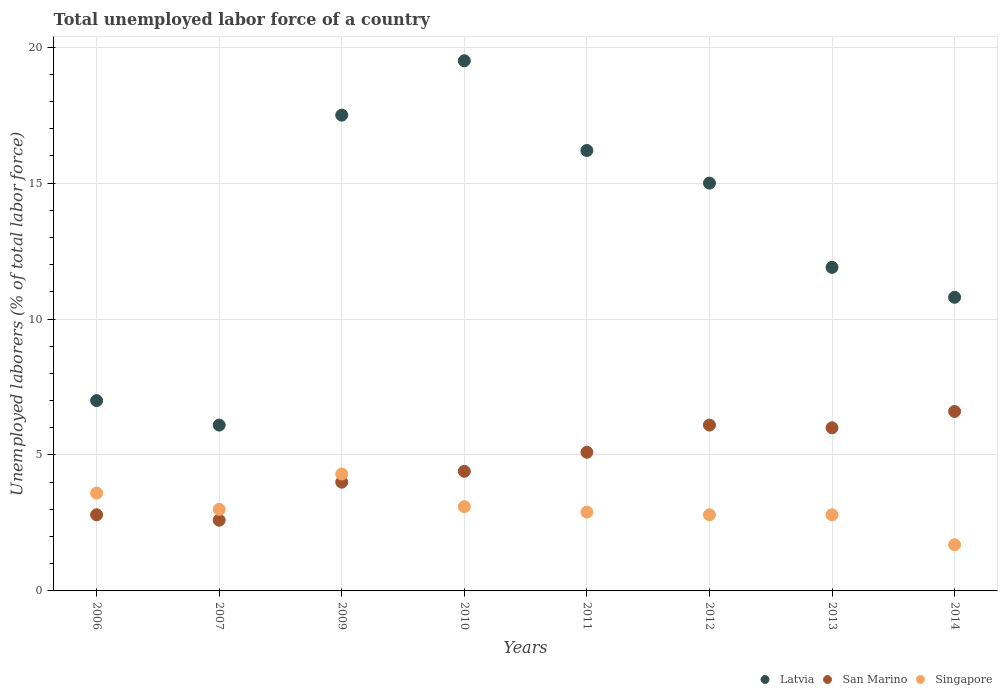How many different coloured dotlines are there?
Provide a succinct answer. 3. Is the number of dotlines equal to the number of legend labels?
Ensure brevity in your answer.  Yes. What is the total unemployed labor force in San Marino in 2012?
Make the answer very short. 6.1. Across all years, what is the maximum total unemployed labor force in Singapore?
Your answer should be compact. 4.3. Across all years, what is the minimum total unemployed labor force in Latvia?
Provide a succinct answer. 6.1. What is the total total unemployed labor force in Singapore in the graph?
Your answer should be very brief. 24.2. What is the difference between the total unemployed labor force in San Marino in 2012 and that in 2013?
Offer a very short reply. 0.1. What is the difference between the total unemployed labor force in Singapore in 2013 and the total unemployed labor force in Latvia in 2010?
Give a very brief answer. -16.7. What is the average total unemployed labor force in San Marino per year?
Your answer should be very brief. 4.7. In the year 2014, what is the difference between the total unemployed labor force in Singapore and total unemployed labor force in Latvia?
Offer a terse response. -9.1. In how many years, is the total unemployed labor force in San Marino greater than 15 %?
Your answer should be very brief. 0. What is the ratio of the total unemployed labor force in Singapore in 2007 to that in 2009?
Your answer should be compact. 0.7. Is the difference between the total unemployed labor force in Singapore in 2007 and 2009 greater than the difference between the total unemployed labor force in Latvia in 2007 and 2009?
Give a very brief answer. Yes. What is the difference between the highest and the second highest total unemployed labor force in Singapore?
Provide a succinct answer. 0.7. What is the difference between the highest and the lowest total unemployed labor force in Latvia?
Offer a terse response. 13.4. In how many years, is the total unemployed labor force in Singapore greater than the average total unemployed labor force in Singapore taken over all years?
Your answer should be very brief. 3. How many dotlines are there?
Your answer should be very brief. 3. Does the graph contain any zero values?
Keep it short and to the point. No. How many legend labels are there?
Keep it short and to the point. 3. What is the title of the graph?
Provide a short and direct response. Total unemployed labor force of a country. What is the label or title of the X-axis?
Offer a terse response. Years. What is the label or title of the Y-axis?
Your answer should be very brief. Unemployed laborers (% of total labor force). What is the Unemployed laborers (% of total labor force) of San Marino in 2006?
Ensure brevity in your answer.  2.8. What is the Unemployed laborers (% of total labor force) in Singapore in 2006?
Provide a succinct answer. 3.6. What is the Unemployed laborers (% of total labor force) in Latvia in 2007?
Your response must be concise. 6.1. What is the Unemployed laborers (% of total labor force) in San Marino in 2007?
Your answer should be very brief. 2.6. What is the Unemployed laborers (% of total labor force) in Singapore in 2007?
Keep it short and to the point. 3. What is the Unemployed laborers (% of total labor force) in Singapore in 2009?
Offer a very short reply. 4.3. What is the Unemployed laborers (% of total labor force) in San Marino in 2010?
Give a very brief answer. 4.4. What is the Unemployed laborers (% of total labor force) of Singapore in 2010?
Provide a short and direct response. 3.1. What is the Unemployed laborers (% of total labor force) of Latvia in 2011?
Make the answer very short. 16.2. What is the Unemployed laborers (% of total labor force) in San Marino in 2011?
Make the answer very short. 5.1. What is the Unemployed laborers (% of total labor force) in Singapore in 2011?
Provide a short and direct response. 2.9. What is the Unemployed laborers (% of total labor force) in Latvia in 2012?
Offer a terse response. 15. What is the Unemployed laborers (% of total labor force) of San Marino in 2012?
Provide a succinct answer. 6.1. What is the Unemployed laborers (% of total labor force) of Singapore in 2012?
Make the answer very short. 2.8. What is the Unemployed laborers (% of total labor force) of Latvia in 2013?
Offer a very short reply. 11.9. What is the Unemployed laborers (% of total labor force) of San Marino in 2013?
Your answer should be very brief. 6. What is the Unemployed laborers (% of total labor force) in Singapore in 2013?
Make the answer very short. 2.8. What is the Unemployed laborers (% of total labor force) in Latvia in 2014?
Your answer should be very brief. 10.8. What is the Unemployed laborers (% of total labor force) of San Marino in 2014?
Provide a succinct answer. 6.6. What is the Unemployed laborers (% of total labor force) in Singapore in 2014?
Offer a terse response. 1.7. Across all years, what is the maximum Unemployed laborers (% of total labor force) in San Marino?
Your answer should be compact. 6.6. Across all years, what is the maximum Unemployed laborers (% of total labor force) of Singapore?
Your response must be concise. 4.3. Across all years, what is the minimum Unemployed laborers (% of total labor force) of Latvia?
Give a very brief answer. 6.1. Across all years, what is the minimum Unemployed laborers (% of total labor force) in San Marino?
Make the answer very short. 2.6. Across all years, what is the minimum Unemployed laborers (% of total labor force) in Singapore?
Keep it short and to the point. 1.7. What is the total Unemployed laborers (% of total labor force) in Latvia in the graph?
Your answer should be compact. 104. What is the total Unemployed laborers (% of total labor force) in San Marino in the graph?
Make the answer very short. 37.6. What is the total Unemployed laborers (% of total labor force) of Singapore in the graph?
Give a very brief answer. 24.2. What is the difference between the Unemployed laborers (% of total labor force) of Latvia in 2006 and that in 2007?
Your answer should be compact. 0.9. What is the difference between the Unemployed laborers (% of total labor force) of San Marino in 2006 and that in 2007?
Your response must be concise. 0.2. What is the difference between the Unemployed laborers (% of total labor force) of Latvia in 2006 and that in 2009?
Your answer should be very brief. -10.5. What is the difference between the Unemployed laborers (% of total labor force) in San Marino in 2006 and that in 2009?
Ensure brevity in your answer.  -1.2. What is the difference between the Unemployed laborers (% of total labor force) in Singapore in 2006 and that in 2010?
Give a very brief answer. 0.5. What is the difference between the Unemployed laborers (% of total labor force) in Latvia in 2006 and that in 2011?
Provide a short and direct response. -9.2. What is the difference between the Unemployed laborers (% of total labor force) of San Marino in 2006 and that in 2011?
Offer a terse response. -2.3. What is the difference between the Unemployed laborers (% of total labor force) of San Marino in 2006 and that in 2012?
Keep it short and to the point. -3.3. What is the difference between the Unemployed laborers (% of total labor force) in Latvia in 2007 and that in 2012?
Your response must be concise. -8.9. What is the difference between the Unemployed laborers (% of total labor force) of Singapore in 2009 and that in 2010?
Your response must be concise. 1.2. What is the difference between the Unemployed laborers (% of total labor force) of Latvia in 2009 and that in 2011?
Offer a terse response. 1.3. What is the difference between the Unemployed laborers (% of total labor force) in San Marino in 2009 and that in 2012?
Offer a very short reply. -2.1. What is the difference between the Unemployed laborers (% of total labor force) of Latvia in 2009 and that in 2013?
Your response must be concise. 5.6. What is the difference between the Unemployed laborers (% of total labor force) in San Marino in 2009 and that in 2013?
Keep it short and to the point. -2. What is the difference between the Unemployed laborers (% of total labor force) of Singapore in 2009 and that in 2013?
Give a very brief answer. 1.5. What is the difference between the Unemployed laborers (% of total labor force) of Latvia in 2009 and that in 2014?
Keep it short and to the point. 6.7. What is the difference between the Unemployed laborers (% of total labor force) of Singapore in 2009 and that in 2014?
Your response must be concise. 2.6. What is the difference between the Unemployed laborers (% of total labor force) in Latvia in 2010 and that in 2012?
Provide a short and direct response. 4.5. What is the difference between the Unemployed laborers (% of total labor force) of Singapore in 2010 and that in 2012?
Your answer should be compact. 0.3. What is the difference between the Unemployed laborers (% of total labor force) in Latvia in 2010 and that in 2013?
Your answer should be compact. 7.6. What is the difference between the Unemployed laborers (% of total labor force) in Singapore in 2010 and that in 2013?
Keep it short and to the point. 0.3. What is the difference between the Unemployed laborers (% of total labor force) in Singapore in 2010 and that in 2014?
Your response must be concise. 1.4. What is the difference between the Unemployed laborers (% of total labor force) in San Marino in 2011 and that in 2012?
Ensure brevity in your answer.  -1. What is the difference between the Unemployed laborers (% of total labor force) of Latvia in 2011 and that in 2013?
Make the answer very short. 4.3. What is the difference between the Unemployed laborers (% of total labor force) of San Marino in 2011 and that in 2013?
Your answer should be very brief. -0.9. What is the difference between the Unemployed laborers (% of total labor force) in Singapore in 2011 and that in 2013?
Your answer should be very brief. 0.1. What is the difference between the Unemployed laborers (% of total labor force) of Singapore in 2011 and that in 2014?
Your answer should be very brief. 1.2. What is the difference between the Unemployed laborers (% of total labor force) of Latvia in 2012 and that in 2013?
Give a very brief answer. 3.1. What is the difference between the Unemployed laborers (% of total labor force) of Latvia in 2012 and that in 2014?
Provide a short and direct response. 4.2. What is the difference between the Unemployed laborers (% of total labor force) of Singapore in 2012 and that in 2014?
Offer a very short reply. 1.1. What is the difference between the Unemployed laborers (% of total labor force) of Singapore in 2013 and that in 2014?
Give a very brief answer. 1.1. What is the difference between the Unemployed laborers (% of total labor force) of San Marino in 2006 and the Unemployed laborers (% of total labor force) of Singapore in 2007?
Give a very brief answer. -0.2. What is the difference between the Unemployed laborers (% of total labor force) in Latvia in 2006 and the Unemployed laborers (% of total labor force) in Singapore in 2010?
Make the answer very short. 3.9. What is the difference between the Unemployed laborers (% of total labor force) of San Marino in 2006 and the Unemployed laborers (% of total labor force) of Singapore in 2010?
Offer a very short reply. -0.3. What is the difference between the Unemployed laborers (% of total labor force) of Latvia in 2006 and the Unemployed laborers (% of total labor force) of Singapore in 2012?
Provide a short and direct response. 4.2. What is the difference between the Unemployed laborers (% of total labor force) of Latvia in 2006 and the Unemployed laborers (% of total labor force) of Singapore in 2013?
Your answer should be compact. 4.2. What is the difference between the Unemployed laborers (% of total labor force) of San Marino in 2006 and the Unemployed laborers (% of total labor force) of Singapore in 2013?
Your response must be concise. 0. What is the difference between the Unemployed laborers (% of total labor force) of Latvia in 2006 and the Unemployed laborers (% of total labor force) of San Marino in 2014?
Give a very brief answer. 0.4. What is the difference between the Unemployed laborers (% of total labor force) in San Marino in 2006 and the Unemployed laborers (% of total labor force) in Singapore in 2014?
Give a very brief answer. 1.1. What is the difference between the Unemployed laborers (% of total labor force) of Latvia in 2007 and the Unemployed laborers (% of total labor force) of San Marino in 2009?
Your answer should be very brief. 2.1. What is the difference between the Unemployed laborers (% of total labor force) of Latvia in 2007 and the Unemployed laborers (% of total labor force) of San Marino in 2010?
Give a very brief answer. 1.7. What is the difference between the Unemployed laborers (% of total labor force) in San Marino in 2007 and the Unemployed laborers (% of total labor force) in Singapore in 2011?
Offer a terse response. -0.3. What is the difference between the Unemployed laborers (% of total labor force) in Latvia in 2007 and the Unemployed laborers (% of total labor force) in San Marino in 2012?
Offer a very short reply. 0. What is the difference between the Unemployed laborers (% of total labor force) of Latvia in 2007 and the Unemployed laborers (% of total labor force) of San Marino in 2013?
Make the answer very short. 0.1. What is the difference between the Unemployed laborers (% of total labor force) in Latvia in 2007 and the Unemployed laborers (% of total labor force) in Singapore in 2013?
Provide a short and direct response. 3.3. What is the difference between the Unemployed laborers (% of total labor force) in San Marino in 2007 and the Unemployed laborers (% of total labor force) in Singapore in 2013?
Offer a very short reply. -0.2. What is the difference between the Unemployed laborers (% of total labor force) in Latvia in 2007 and the Unemployed laborers (% of total labor force) in San Marino in 2014?
Give a very brief answer. -0.5. What is the difference between the Unemployed laborers (% of total labor force) of San Marino in 2007 and the Unemployed laborers (% of total labor force) of Singapore in 2014?
Your response must be concise. 0.9. What is the difference between the Unemployed laborers (% of total labor force) of Latvia in 2009 and the Unemployed laborers (% of total labor force) of San Marino in 2010?
Your answer should be compact. 13.1. What is the difference between the Unemployed laborers (% of total labor force) in Latvia in 2009 and the Unemployed laborers (% of total labor force) in Singapore in 2010?
Give a very brief answer. 14.4. What is the difference between the Unemployed laborers (% of total labor force) of San Marino in 2009 and the Unemployed laborers (% of total labor force) of Singapore in 2010?
Make the answer very short. 0.9. What is the difference between the Unemployed laborers (% of total labor force) of Latvia in 2009 and the Unemployed laborers (% of total labor force) of Singapore in 2011?
Provide a short and direct response. 14.6. What is the difference between the Unemployed laborers (% of total labor force) of Latvia in 2009 and the Unemployed laborers (% of total labor force) of Singapore in 2012?
Make the answer very short. 14.7. What is the difference between the Unemployed laborers (% of total labor force) in Latvia in 2009 and the Unemployed laborers (% of total labor force) in San Marino in 2013?
Your answer should be compact. 11.5. What is the difference between the Unemployed laborers (% of total labor force) in Latvia in 2009 and the Unemployed laborers (% of total labor force) in Singapore in 2013?
Give a very brief answer. 14.7. What is the difference between the Unemployed laborers (% of total labor force) in San Marino in 2009 and the Unemployed laborers (% of total labor force) in Singapore in 2013?
Ensure brevity in your answer.  1.2. What is the difference between the Unemployed laborers (% of total labor force) in Latvia in 2010 and the Unemployed laborers (% of total labor force) in San Marino in 2011?
Your answer should be very brief. 14.4. What is the difference between the Unemployed laborers (% of total labor force) of Latvia in 2010 and the Unemployed laborers (% of total labor force) of Singapore in 2011?
Your answer should be compact. 16.6. What is the difference between the Unemployed laborers (% of total labor force) of San Marino in 2010 and the Unemployed laborers (% of total labor force) of Singapore in 2011?
Make the answer very short. 1.5. What is the difference between the Unemployed laborers (% of total labor force) of Latvia in 2010 and the Unemployed laborers (% of total labor force) of San Marino in 2012?
Provide a short and direct response. 13.4. What is the difference between the Unemployed laborers (% of total labor force) in San Marino in 2010 and the Unemployed laborers (% of total labor force) in Singapore in 2012?
Make the answer very short. 1.6. What is the difference between the Unemployed laborers (% of total labor force) of Latvia in 2010 and the Unemployed laborers (% of total labor force) of San Marino in 2013?
Provide a succinct answer. 13.5. What is the difference between the Unemployed laborers (% of total labor force) of Latvia in 2010 and the Unemployed laborers (% of total labor force) of Singapore in 2013?
Ensure brevity in your answer.  16.7. What is the difference between the Unemployed laborers (% of total labor force) in Latvia in 2010 and the Unemployed laborers (% of total labor force) in San Marino in 2014?
Make the answer very short. 12.9. What is the difference between the Unemployed laborers (% of total labor force) of Latvia in 2010 and the Unemployed laborers (% of total labor force) of Singapore in 2014?
Ensure brevity in your answer.  17.8. What is the difference between the Unemployed laborers (% of total labor force) of San Marino in 2010 and the Unemployed laborers (% of total labor force) of Singapore in 2014?
Provide a short and direct response. 2.7. What is the difference between the Unemployed laborers (% of total labor force) in Latvia in 2011 and the Unemployed laborers (% of total labor force) in San Marino in 2012?
Give a very brief answer. 10.1. What is the difference between the Unemployed laborers (% of total labor force) of Latvia in 2011 and the Unemployed laborers (% of total labor force) of San Marino in 2013?
Your answer should be very brief. 10.2. What is the difference between the Unemployed laborers (% of total labor force) in San Marino in 2011 and the Unemployed laborers (% of total labor force) in Singapore in 2013?
Your answer should be compact. 2.3. What is the difference between the Unemployed laborers (% of total labor force) in Latvia in 2011 and the Unemployed laborers (% of total labor force) in San Marino in 2014?
Your answer should be very brief. 9.6. What is the difference between the Unemployed laborers (% of total labor force) of Latvia in 2012 and the Unemployed laborers (% of total labor force) of San Marino in 2013?
Provide a succinct answer. 9. What is the difference between the Unemployed laborers (% of total labor force) in San Marino in 2012 and the Unemployed laborers (% of total labor force) in Singapore in 2013?
Give a very brief answer. 3.3. What is the difference between the Unemployed laborers (% of total labor force) in Latvia in 2012 and the Unemployed laborers (% of total labor force) in Singapore in 2014?
Provide a succinct answer. 13.3. What is the difference between the Unemployed laborers (% of total labor force) in San Marino in 2012 and the Unemployed laborers (% of total labor force) in Singapore in 2014?
Offer a terse response. 4.4. What is the average Unemployed laborers (% of total labor force) in Latvia per year?
Provide a succinct answer. 13. What is the average Unemployed laborers (% of total labor force) of San Marino per year?
Provide a succinct answer. 4.7. What is the average Unemployed laborers (% of total labor force) in Singapore per year?
Offer a terse response. 3.02. In the year 2006, what is the difference between the Unemployed laborers (% of total labor force) in Latvia and Unemployed laborers (% of total labor force) in San Marino?
Keep it short and to the point. 4.2. In the year 2007, what is the difference between the Unemployed laborers (% of total labor force) in Latvia and Unemployed laborers (% of total labor force) in Singapore?
Your response must be concise. 3.1. In the year 2009, what is the difference between the Unemployed laborers (% of total labor force) of San Marino and Unemployed laborers (% of total labor force) of Singapore?
Your answer should be very brief. -0.3. In the year 2010, what is the difference between the Unemployed laborers (% of total labor force) of Latvia and Unemployed laborers (% of total labor force) of San Marino?
Give a very brief answer. 15.1. In the year 2010, what is the difference between the Unemployed laborers (% of total labor force) in Latvia and Unemployed laborers (% of total labor force) in Singapore?
Your response must be concise. 16.4. In the year 2011, what is the difference between the Unemployed laborers (% of total labor force) of Latvia and Unemployed laborers (% of total labor force) of San Marino?
Provide a succinct answer. 11.1. In the year 2011, what is the difference between the Unemployed laborers (% of total labor force) of Latvia and Unemployed laborers (% of total labor force) of Singapore?
Provide a succinct answer. 13.3. In the year 2012, what is the difference between the Unemployed laborers (% of total labor force) of Latvia and Unemployed laborers (% of total labor force) of San Marino?
Offer a very short reply. 8.9. In the year 2012, what is the difference between the Unemployed laborers (% of total labor force) of Latvia and Unemployed laborers (% of total labor force) of Singapore?
Offer a terse response. 12.2. In the year 2013, what is the difference between the Unemployed laborers (% of total labor force) of Latvia and Unemployed laborers (% of total labor force) of San Marino?
Your answer should be very brief. 5.9. What is the ratio of the Unemployed laborers (% of total labor force) in Latvia in 2006 to that in 2007?
Give a very brief answer. 1.15. What is the ratio of the Unemployed laborers (% of total labor force) in Singapore in 2006 to that in 2007?
Make the answer very short. 1.2. What is the ratio of the Unemployed laborers (% of total labor force) of San Marino in 2006 to that in 2009?
Your answer should be compact. 0.7. What is the ratio of the Unemployed laborers (% of total labor force) in Singapore in 2006 to that in 2009?
Keep it short and to the point. 0.84. What is the ratio of the Unemployed laborers (% of total labor force) in Latvia in 2006 to that in 2010?
Your response must be concise. 0.36. What is the ratio of the Unemployed laborers (% of total labor force) of San Marino in 2006 to that in 2010?
Provide a succinct answer. 0.64. What is the ratio of the Unemployed laborers (% of total labor force) in Singapore in 2006 to that in 2010?
Your response must be concise. 1.16. What is the ratio of the Unemployed laborers (% of total labor force) of Latvia in 2006 to that in 2011?
Your response must be concise. 0.43. What is the ratio of the Unemployed laborers (% of total labor force) in San Marino in 2006 to that in 2011?
Provide a succinct answer. 0.55. What is the ratio of the Unemployed laborers (% of total labor force) in Singapore in 2006 to that in 2011?
Your answer should be compact. 1.24. What is the ratio of the Unemployed laborers (% of total labor force) in Latvia in 2006 to that in 2012?
Keep it short and to the point. 0.47. What is the ratio of the Unemployed laborers (% of total labor force) in San Marino in 2006 to that in 2012?
Your answer should be compact. 0.46. What is the ratio of the Unemployed laborers (% of total labor force) in Latvia in 2006 to that in 2013?
Keep it short and to the point. 0.59. What is the ratio of the Unemployed laborers (% of total labor force) of San Marino in 2006 to that in 2013?
Ensure brevity in your answer.  0.47. What is the ratio of the Unemployed laborers (% of total labor force) in Singapore in 2006 to that in 2013?
Your answer should be very brief. 1.29. What is the ratio of the Unemployed laborers (% of total labor force) of Latvia in 2006 to that in 2014?
Provide a succinct answer. 0.65. What is the ratio of the Unemployed laborers (% of total labor force) in San Marino in 2006 to that in 2014?
Provide a short and direct response. 0.42. What is the ratio of the Unemployed laborers (% of total labor force) of Singapore in 2006 to that in 2014?
Provide a succinct answer. 2.12. What is the ratio of the Unemployed laborers (% of total labor force) of Latvia in 2007 to that in 2009?
Ensure brevity in your answer.  0.35. What is the ratio of the Unemployed laborers (% of total labor force) of San Marino in 2007 to that in 2009?
Your response must be concise. 0.65. What is the ratio of the Unemployed laborers (% of total labor force) of Singapore in 2007 to that in 2009?
Make the answer very short. 0.7. What is the ratio of the Unemployed laborers (% of total labor force) of Latvia in 2007 to that in 2010?
Keep it short and to the point. 0.31. What is the ratio of the Unemployed laborers (% of total labor force) in San Marino in 2007 to that in 2010?
Ensure brevity in your answer.  0.59. What is the ratio of the Unemployed laborers (% of total labor force) in Singapore in 2007 to that in 2010?
Keep it short and to the point. 0.97. What is the ratio of the Unemployed laborers (% of total labor force) of Latvia in 2007 to that in 2011?
Offer a terse response. 0.38. What is the ratio of the Unemployed laborers (% of total labor force) in San Marino in 2007 to that in 2011?
Offer a terse response. 0.51. What is the ratio of the Unemployed laborers (% of total labor force) of Singapore in 2007 to that in 2011?
Make the answer very short. 1.03. What is the ratio of the Unemployed laborers (% of total labor force) of Latvia in 2007 to that in 2012?
Your answer should be compact. 0.41. What is the ratio of the Unemployed laborers (% of total labor force) in San Marino in 2007 to that in 2012?
Ensure brevity in your answer.  0.43. What is the ratio of the Unemployed laborers (% of total labor force) in Singapore in 2007 to that in 2012?
Give a very brief answer. 1.07. What is the ratio of the Unemployed laborers (% of total labor force) of Latvia in 2007 to that in 2013?
Your answer should be compact. 0.51. What is the ratio of the Unemployed laborers (% of total labor force) in San Marino in 2007 to that in 2013?
Your response must be concise. 0.43. What is the ratio of the Unemployed laborers (% of total labor force) in Singapore in 2007 to that in 2013?
Provide a succinct answer. 1.07. What is the ratio of the Unemployed laborers (% of total labor force) in Latvia in 2007 to that in 2014?
Provide a succinct answer. 0.56. What is the ratio of the Unemployed laborers (% of total labor force) in San Marino in 2007 to that in 2014?
Give a very brief answer. 0.39. What is the ratio of the Unemployed laborers (% of total labor force) in Singapore in 2007 to that in 2014?
Keep it short and to the point. 1.76. What is the ratio of the Unemployed laborers (% of total labor force) in Latvia in 2009 to that in 2010?
Your answer should be very brief. 0.9. What is the ratio of the Unemployed laborers (% of total labor force) of Singapore in 2009 to that in 2010?
Your response must be concise. 1.39. What is the ratio of the Unemployed laborers (% of total labor force) of Latvia in 2009 to that in 2011?
Offer a terse response. 1.08. What is the ratio of the Unemployed laborers (% of total labor force) in San Marino in 2009 to that in 2011?
Your answer should be compact. 0.78. What is the ratio of the Unemployed laborers (% of total labor force) in Singapore in 2009 to that in 2011?
Your answer should be very brief. 1.48. What is the ratio of the Unemployed laborers (% of total labor force) of Latvia in 2009 to that in 2012?
Your response must be concise. 1.17. What is the ratio of the Unemployed laborers (% of total labor force) of San Marino in 2009 to that in 2012?
Offer a very short reply. 0.66. What is the ratio of the Unemployed laborers (% of total labor force) of Singapore in 2009 to that in 2012?
Provide a short and direct response. 1.54. What is the ratio of the Unemployed laborers (% of total labor force) of Latvia in 2009 to that in 2013?
Your answer should be very brief. 1.47. What is the ratio of the Unemployed laborers (% of total labor force) of San Marino in 2009 to that in 2013?
Your answer should be compact. 0.67. What is the ratio of the Unemployed laborers (% of total labor force) in Singapore in 2009 to that in 2013?
Provide a short and direct response. 1.54. What is the ratio of the Unemployed laborers (% of total labor force) of Latvia in 2009 to that in 2014?
Make the answer very short. 1.62. What is the ratio of the Unemployed laborers (% of total labor force) in San Marino in 2009 to that in 2014?
Offer a very short reply. 0.61. What is the ratio of the Unemployed laborers (% of total labor force) of Singapore in 2009 to that in 2014?
Provide a succinct answer. 2.53. What is the ratio of the Unemployed laborers (% of total labor force) of Latvia in 2010 to that in 2011?
Your answer should be compact. 1.2. What is the ratio of the Unemployed laborers (% of total labor force) of San Marino in 2010 to that in 2011?
Offer a very short reply. 0.86. What is the ratio of the Unemployed laborers (% of total labor force) in Singapore in 2010 to that in 2011?
Your answer should be compact. 1.07. What is the ratio of the Unemployed laborers (% of total labor force) of San Marino in 2010 to that in 2012?
Give a very brief answer. 0.72. What is the ratio of the Unemployed laborers (% of total labor force) in Singapore in 2010 to that in 2012?
Your answer should be compact. 1.11. What is the ratio of the Unemployed laborers (% of total labor force) of Latvia in 2010 to that in 2013?
Keep it short and to the point. 1.64. What is the ratio of the Unemployed laborers (% of total labor force) of San Marino in 2010 to that in 2013?
Your answer should be very brief. 0.73. What is the ratio of the Unemployed laborers (% of total labor force) of Singapore in 2010 to that in 2013?
Provide a succinct answer. 1.11. What is the ratio of the Unemployed laborers (% of total labor force) in Latvia in 2010 to that in 2014?
Offer a terse response. 1.81. What is the ratio of the Unemployed laborers (% of total labor force) of Singapore in 2010 to that in 2014?
Provide a succinct answer. 1.82. What is the ratio of the Unemployed laborers (% of total labor force) of Latvia in 2011 to that in 2012?
Offer a very short reply. 1.08. What is the ratio of the Unemployed laborers (% of total labor force) of San Marino in 2011 to that in 2012?
Give a very brief answer. 0.84. What is the ratio of the Unemployed laborers (% of total labor force) in Singapore in 2011 to that in 2012?
Provide a short and direct response. 1.04. What is the ratio of the Unemployed laborers (% of total labor force) of Latvia in 2011 to that in 2013?
Provide a succinct answer. 1.36. What is the ratio of the Unemployed laborers (% of total labor force) of Singapore in 2011 to that in 2013?
Offer a very short reply. 1.04. What is the ratio of the Unemployed laborers (% of total labor force) in Latvia in 2011 to that in 2014?
Offer a very short reply. 1.5. What is the ratio of the Unemployed laborers (% of total labor force) in San Marino in 2011 to that in 2014?
Offer a very short reply. 0.77. What is the ratio of the Unemployed laborers (% of total labor force) in Singapore in 2011 to that in 2014?
Your answer should be compact. 1.71. What is the ratio of the Unemployed laborers (% of total labor force) in Latvia in 2012 to that in 2013?
Your answer should be compact. 1.26. What is the ratio of the Unemployed laborers (% of total labor force) of San Marino in 2012 to that in 2013?
Offer a very short reply. 1.02. What is the ratio of the Unemployed laborers (% of total labor force) in Latvia in 2012 to that in 2014?
Ensure brevity in your answer.  1.39. What is the ratio of the Unemployed laborers (% of total labor force) in San Marino in 2012 to that in 2014?
Your answer should be compact. 0.92. What is the ratio of the Unemployed laborers (% of total labor force) in Singapore in 2012 to that in 2014?
Give a very brief answer. 1.65. What is the ratio of the Unemployed laborers (% of total labor force) of Latvia in 2013 to that in 2014?
Provide a succinct answer. 1.1. What is the ratio of the Unemployed laborers (% of total labor force) of San Marino in 2013 to that in 2014?
Provide a succinct answer. 0.91. What is the ratio of the Unemployed laborers (% of total labor force) of Singapore in 2013 to that in 2014?
Your answer should be very brief. 1.65. What is the difference between the highest and the second highest Unemployed laborers (% of total labor force) of San Marino?
Offer a terse response. 0.5. What is the difference between the highest and the second highest Unemployed laborers (% of total labor force) in Singapore?
Your response must be concise. 0.7. What is the difference between the highest and the lowest Unemployed laborers (% of total labor force) in Latvia?
Offer a very short reply. 13.4. What is the difference between the highest and the lowest Unemployed laborers (% of total labor force) in Singapore?
Provide a short and direct response. 2.6. 